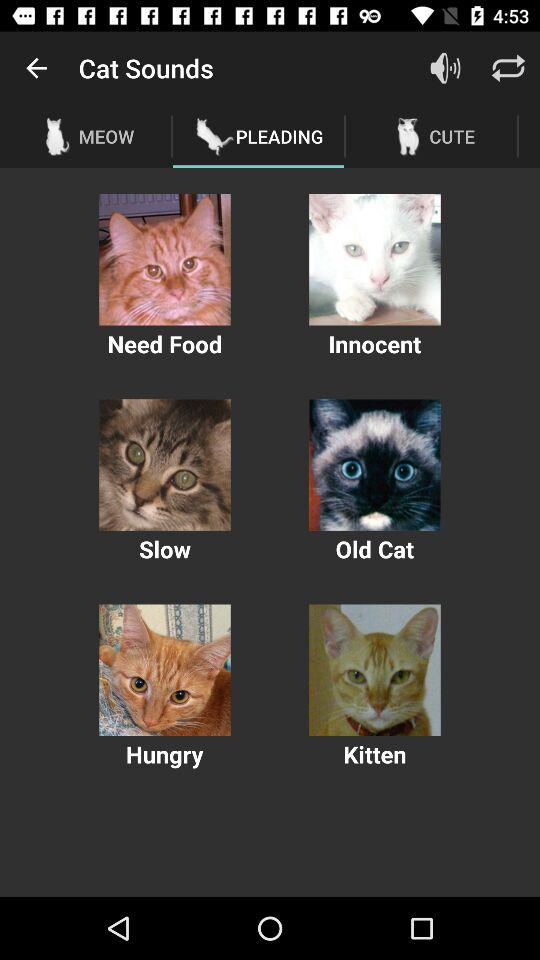Which option is selected in "Cat Sounds"? The selected option is "PLEADING". 